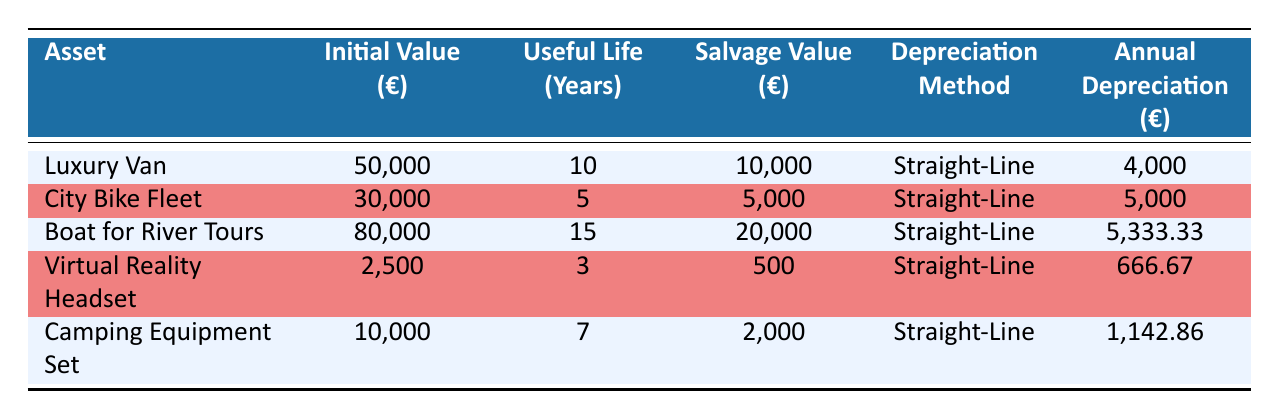What is the initial value of the Luxury Van? The table lists the initial value of the Luxury Van under the "Initial Value (€)" column. It shows a value of 50,000 euros.
Answer: 50,000 euros How many years is the useful life of the City Bike Fleet? The useful life for the City Bike Fleet is found in the "Useful Life (Years)" column. It states that the useful life is 5 years.
Answer: 5 years Is the depreciation method for the Boat for River Tours Straight-Line? The "Depreciation Method" for the Boat for River Tours is found in the corresponding row, which states that it is "Straight-Line." Thus, the statement is true.
Answer: Yes What is the total annual depreciation for all assets combined? To find the total annual depreciation, we sum the annual depreciation values: 4,000 (Luxury Van) + 5,000 (City Bike Fleet) + 5,333.33 (Boat for River Tours) + 666.67 (Virtual Reality Headset) + 1,142.86 (Camping Equipment Set) = 16,142.86.
Answer: 16,142.86 euros Which asset has the lowest salvage value? By comparing the "Salvage Value (€)" column for all assets, the Virtual Reality Headset has a salvage value of 500 euros, which is the lowest among all listed assets.
Answer: Virtual Reality Headset What is the average annual depreciation for the assets with a useful life of 10 years or more? The assets with a useful life of 10 years or more are the Luxury Van (4,000) and the Boat for River Tours (5,333.33). The average is calculated as (4,000 + 5,333.33) / 2 = 4,666.67.
Answer: 4,666.67 euros Is the highest initial value among the assets related to the Boat for River Tours? By looking at the "Initial Value (€)" column, the Boat for River Tours has an initial value of 80,000 euros, which is higher than all other assets: Luxury Van (50,000), City Bike Fleet (30,000), Virtual Reality Headset (2,500), and Camping Equipment Set (10,000). Hence, the statement is true.
Answer: Yes What is the difference in annual depreciation between the City Bike Fleet and the Virtual Reality Headset? The annual depreciation for the City Bike Fleet is 5,000 euros and for the Virtual Reality Headset is 666.67 euros. The difference is calculated as 5,000 - 666.67 = 4,333.33 euros.
Answer: 4,333.33 euros 